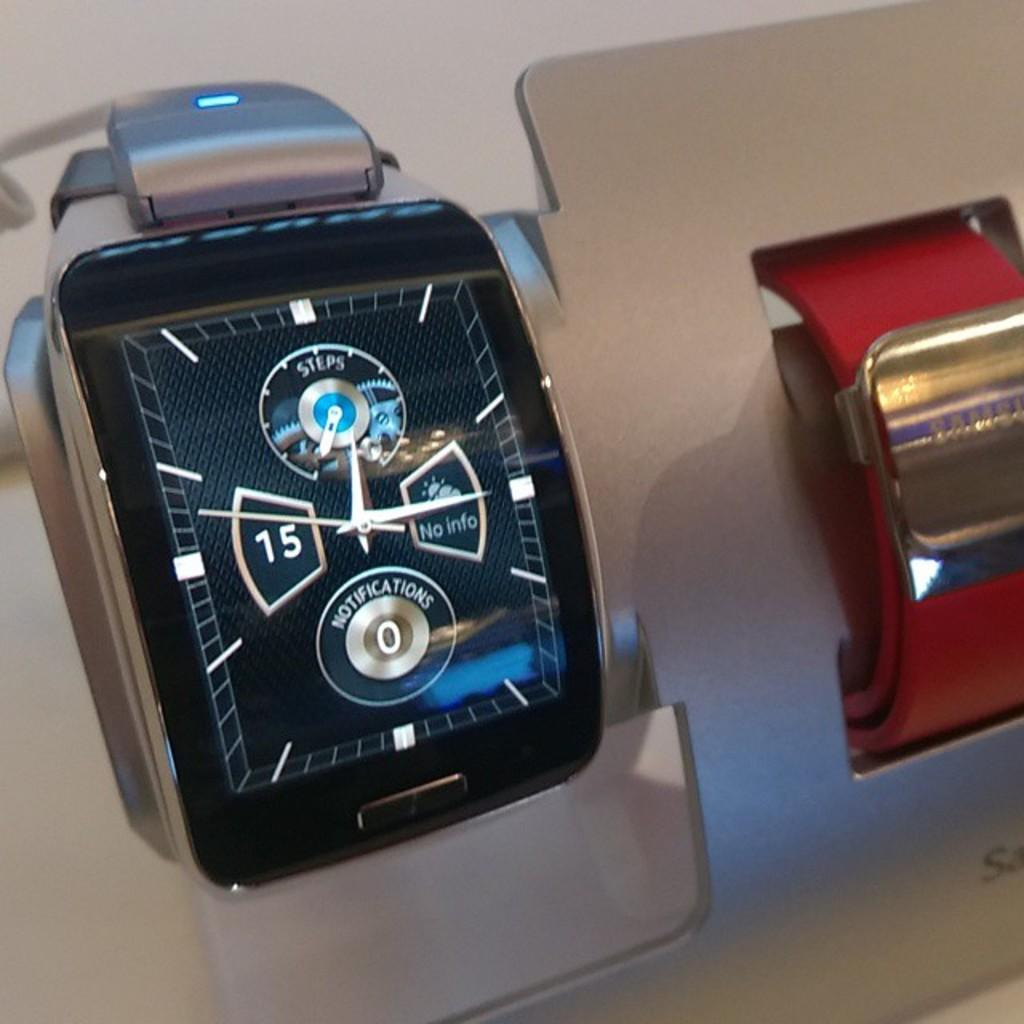<image>
Render a clear and concise summary of the photo. A watch says there are zero notifications and that there is no info. 